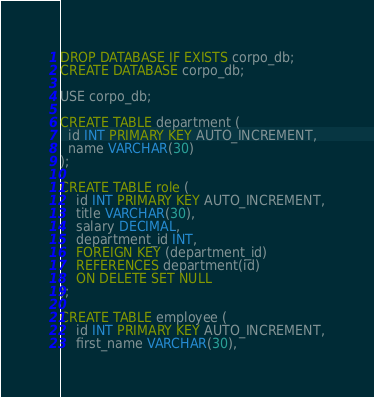<code> <loc_0><loc_0><loc_500><loc_500><_SQL_>DROP DATABASE IF EXISTS corpo_db;
CREATE DATABASE corpo_db;

USE corpo_db;

CREATE TABLE department (
  id INT PRIMARY KEY AUTO_INCREMENT,
  name VARCHAR(30)
);

CREATE TABLE role (
    id INT PRIMARY KEY AUTO_INCREMENT,
    title VARCHAR(30),
    salary DECIMAL,
    department_id INT,
    FOREIGN KEY (department_id)
    REFERENCES department(id)
    ON DELETE SET NULL
);

CREATE TABLE employee (
    id INT PRIMARY KEY AUTO_INCREMENT,
    first_name VARCHAR(30),</code> 